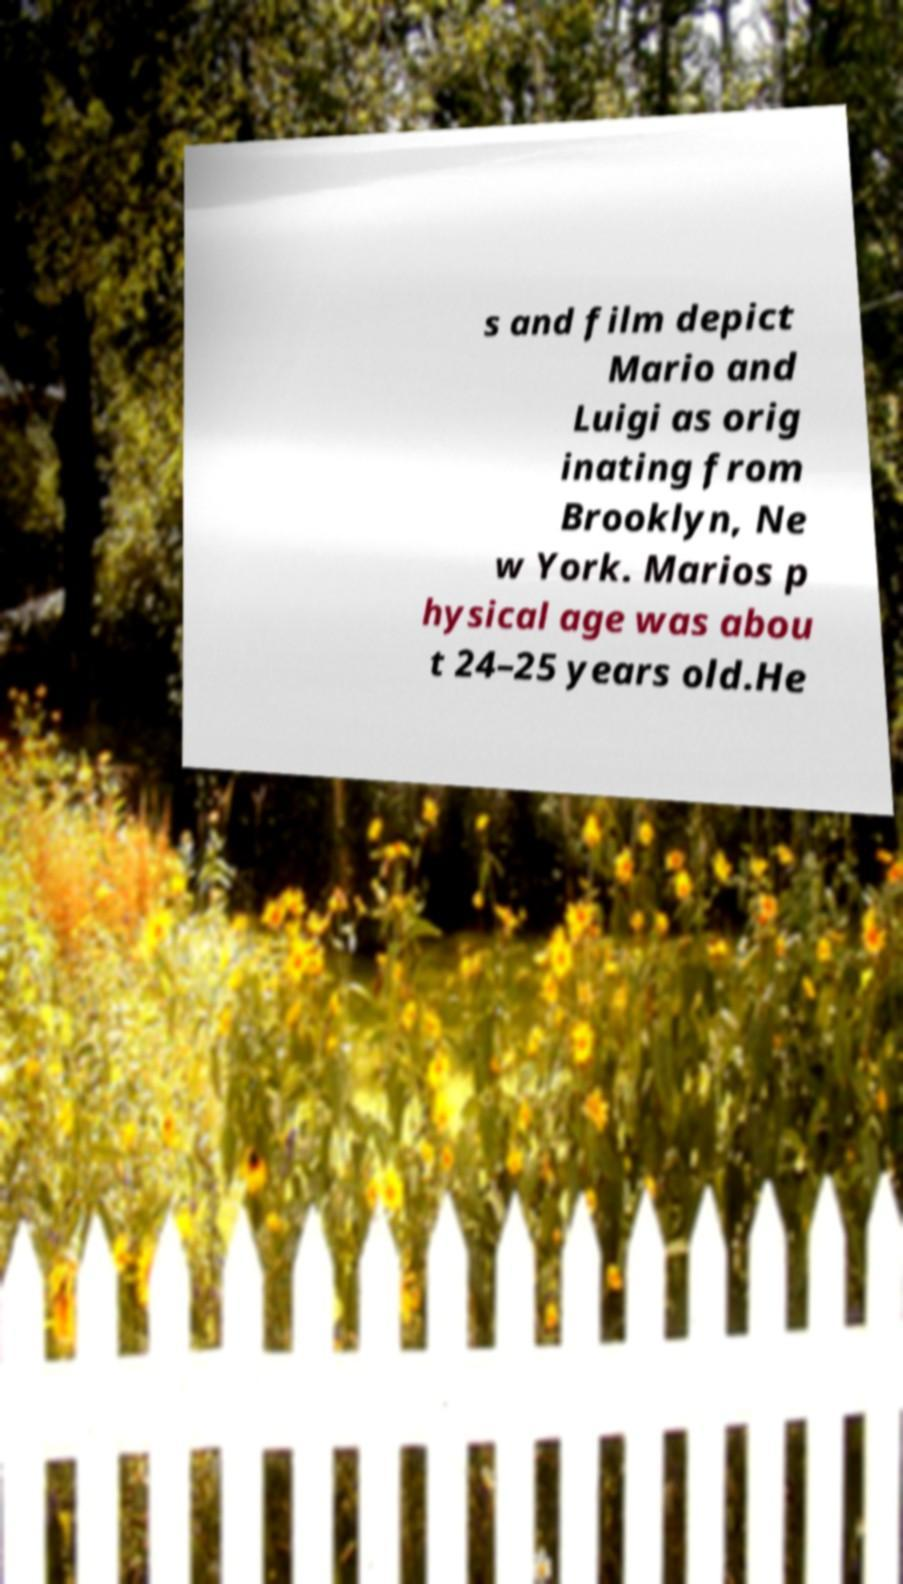Can you read and provide the text displayed in the image?This photo seems to have some interesting text. Can you extract and type it out for me? s and film depict Mario and Luigi as orig inating from Brooklyn, Ne w York. Marios p hysical age was abou t 24–25 years old.He 